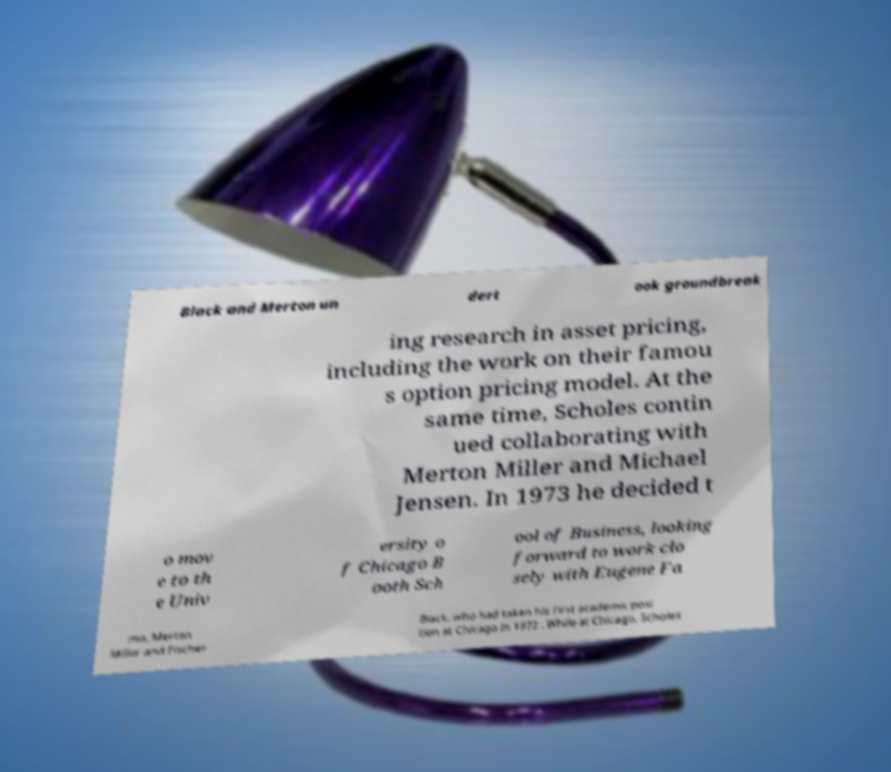What messages or text are displayed in this image? I need them in a readable, typed format. Black and Merton un dert ook groundbreak ing research in asset pricing, including the work on their famou s option pricing model. At the same time, Scholes contin ued collaborating with Merton Miller and Michael Jensen. In 1973 he decided t o mov e to th e Univ ersity o f Chicago B ooth Sch ool of Business, looking forward to work clo sely with Eugene Fa ma, Merton Miller and Fischer Black, who had taken his first academic posi tion at Chicago in 1972 . While at Chicago, Scholes 